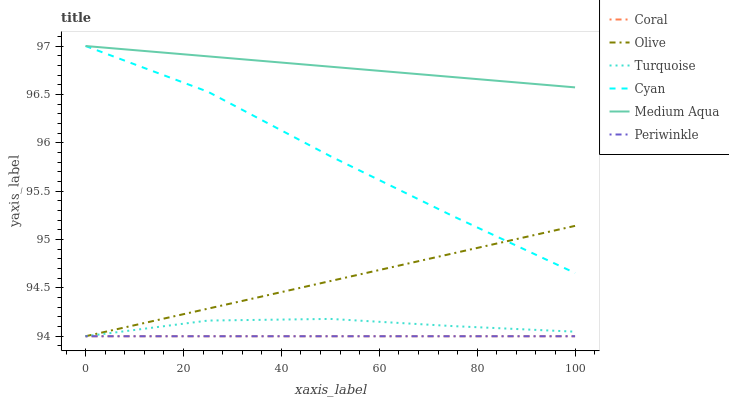Does Coral have the minimum area under the curve?
Answer yes or no. Yes. Does Medium Aqua have the maximum area under the curve?
Answer yes or no. Yes. Does Medium Aqua have the minimum area under the curve?
Answer yes or no. No. Does Periwinkle have the maximum area under the curve?
Answer yes or no. No. Is Coral the smoothest?
Answer yes or no. Yes. Is Cyan the roughest?
Answer yes or no. Yes. Is Medium Aqua the smoothest?
Answer yes or no. No. Is Medium Aqua the roughest?
Answer yes or no. No. Does Medium Aqua have the lowest value?
Answer yes or no. No. Does Periwinkle have the highest value?
Answer yes or no. No. Is Olive less than Medium Aqua?
Answer yes or no. Yes. Is Medium Aqua greater than Periwinkle?
Answer yes or no. Yes. Does Olive intersect Medium Aqua?
Answer yes or no. No. 